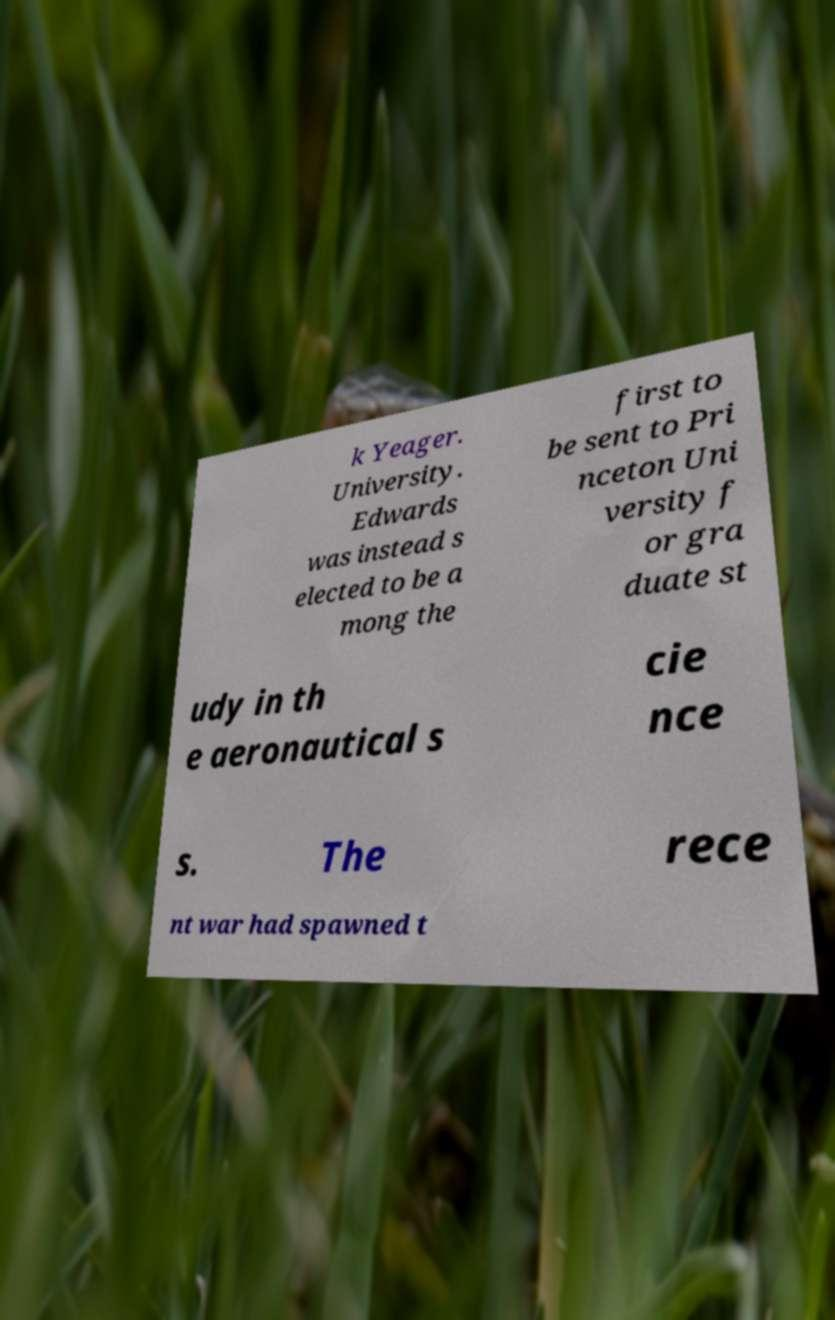Can you read and provide the text displayed in the image?This photo seems to have some interesting text. Can you extract and type it out for me? k Yeager. University. Edwards was instead s elected to be a mong the first to be sent to Pri nceton Uni versity f or gra duate st udy in th e aeronautical s cie nce s. The rece nt war had spawned t 